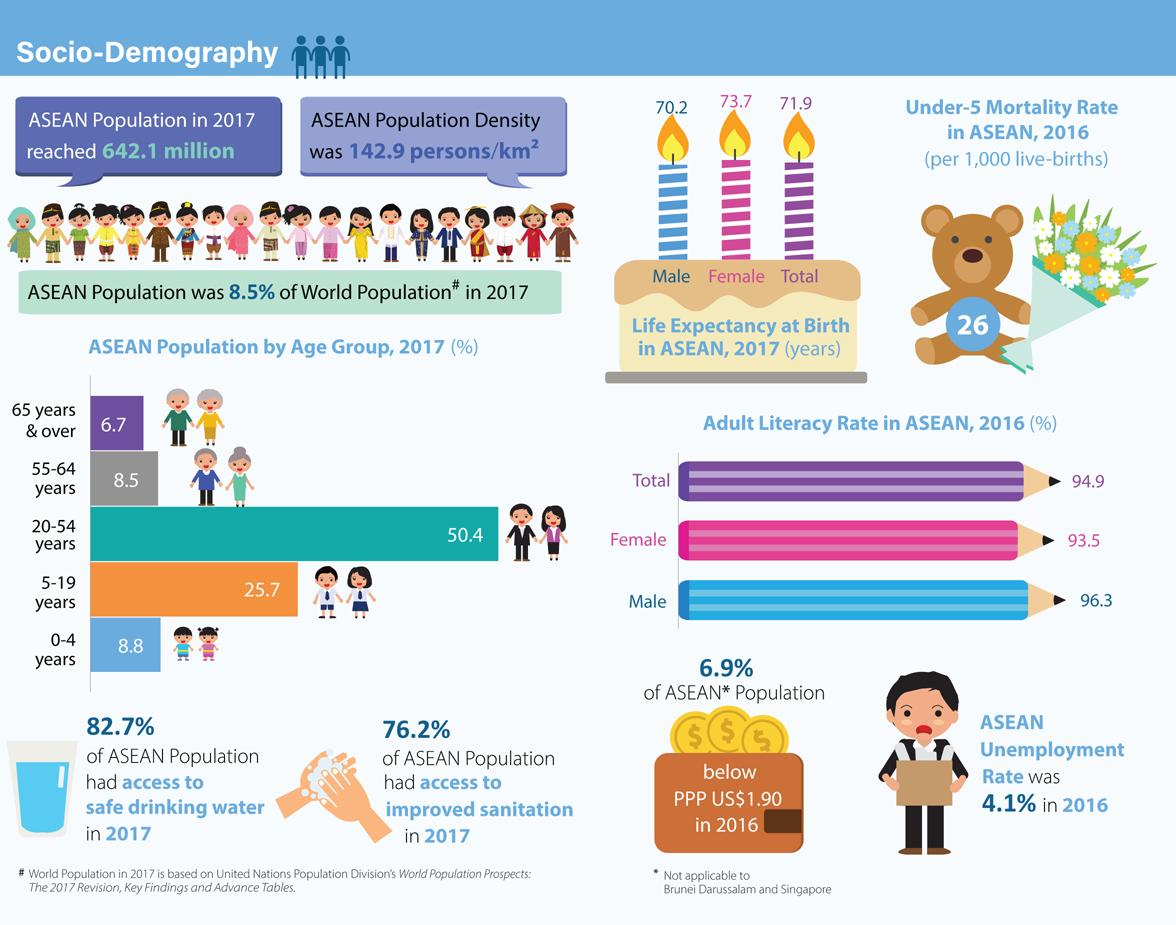Highlight a few significant elements in this photo. The adult literacy rate for females and males taken together is 189.8%. According to data from 2017, the average expected lifespan for females in the ASEAN region was 73.7 years. The male expectancy at birth in ASEAN in 2017 was 70.2 years. In 2017, approximately 82.7% of the ASEAN population had access to safe drinking water. In 2017, 76.2% of the ASEAN population had access to improved sanitation, indicating a significant progress in improving access to sanitation in the region. 